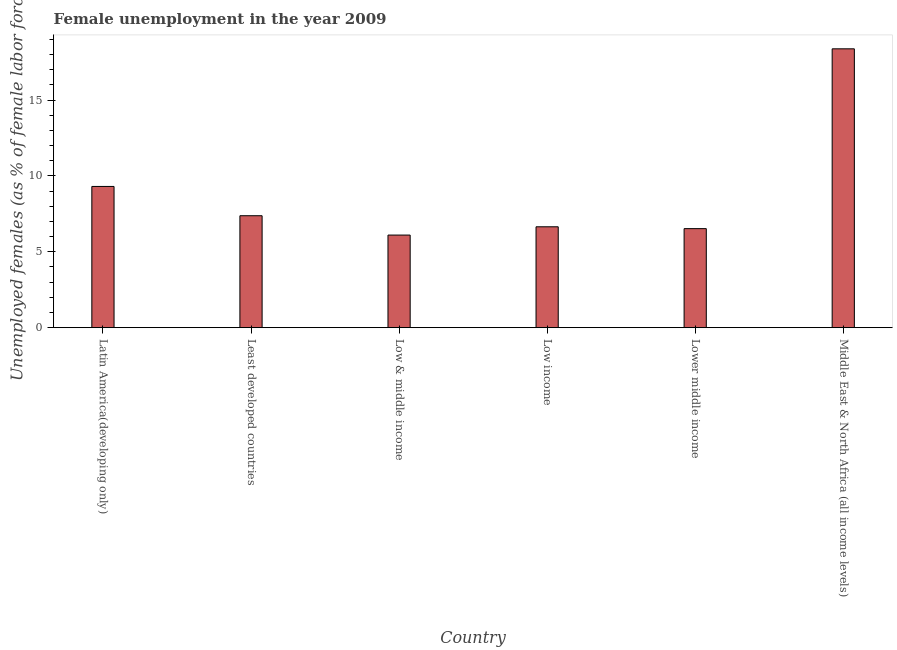Does the graph contain any zero values?
Your response must be concise. No. What is the title of the graph?
Keep it short and to the point. Female unemployment in the year 2009. What is the label or title of the Y-axis?
Provide a succinct answer. Unemployed females (as % of female labor force). What is the unemployed females population in Least developed countries?
Your response must be concise. 7.38. Across all countries, what is the maximum unemployed females population?
Give a very brief answer. 18.39. Across all countries, what is the minimum unemployed females population?
Provide a short and direct response. 6.11. In which country was the unemployed females population maximum?
Provide a succinct answer. Middle East & North Africa (all income levels). In which country was the unemployed females population minimum?
Provide a short and direct response. Low & middle income. What is the sum of the unemployed females population?
Your response must be concise. 54.36. What is the difference between the unemployed females population in Least developed countries and Low income?
Ensure brevity in your answer.  0.73. What is the average unemployed females population per country?
Give a very brief answer. 9.06. What is the median unemployed females population?
Your answer should be very brief. 7.02. Is the unemployed females population in Low & middle income less than that in Lower middle income?
Offer a very short reply. Yes. Is the difference between the unemployed females population in Latin America(developing only) and Lower middle income greater than the difference between any two countries?
Provide a succinct answer. No. What is the difference between the highest and the second highest unemployed females population?
Ensure brevity in your answer.  9.07. Is the sum of the unemployed females population in Low & middle income and Lower middle income greater than the maximum unemployed females population across all countries?
Your response must be concise. No. What is the difference between the highest and the lowest unemployed females population?
Your answer should be very brief. 12.28. In how many countries, is the unemployed females population greater than the average unemployed females population taken over all countries?
Ensure brevity in your answer.  2. How many bars are there?
Ensure brevity in your answer.  6. How many countries are there in the graph?
Your answer should be very brief. 6. Are the values on the major ticks of Y-axis written in scientific E-notation?
Make the answer very short. No. What is the Unemployed females (as % of female labor force) of Latin America(developing only)?
Provide a short and direct response. 9.31. What is the Unemployed females (as % of female labor force) in Least developed countries?
Your answer should be compact. 7.38. What is the Unemployed females (as % of female labor force) of Low & middle income?
Your answer should be very brief. 6.11. What is the Unemployed females (as % of female labor force) of Low income?
Give a very brief answer. 6.65. What is the Unemployed females (as % of female labor force) of Lower middle income?
Your answer should be compact. 6.53. What is the Unemployed females (as % of female labor force) of Middle East & North Africa (all income levels)?
Your answer should be very brief. 18.39. What is the difference between the Unemployed females (as % of female labor force) in Latin America(developing only) and Least developed countries?
Make the answer very short. 1.93. What is the difference between the Unemployed females (as % of female labor force) in Latin America(developing only) and Low & middle income?
Your response must be concise. 3.21. What is the difference between the Unemployed females (as % of female labor force) in Latin America(developing only) and Low income?
Make the answer very short. 2.66. What is the difference between the Unemployed females (as % of female labor force) in Latin America(developing only) and Lower middle income?
Your response must be concise. 2.78. What is the difference between the Unemployed females (as % of female labor force) in Latin America(developing only) and Middle East & North Africa (all income levels)?
Give a very brief answer. -9.07. What is the difference between the Unemployed females (as % of female labor force) in Least developed countries and Low & middle income?
Provide a succinct answer. 1.27. What is the difference between the Unemployed females (as % of female labor force) in Least developed countries and Low income?
Make the answer very short. 0.73. What is the difference between the Unemployed females (as % of female labor force) in Least developed countries and Lower middle income?
Your answer should be very brief. 0.85. What is the difference between the Unemployed females (as % of female labor force) in Least developed countries and Middle East & North Africa (all income levels)?
Offer a terse response. -11.01. What is the difference between the Unemployed females (as % of female labor force) in Low & middle income and Low income?
Keep it short and to the point. -0.55. What is the difference between the Unemployed females (as % of female labor force) in Low & middle income and Lower middle income?
Your answer should be compact. -0.42. What is the difference between the Unemployed females (as % of female labor force) in Low & middle income and Middle East & North Africa (all income levels)?
Your answer should be compact. -12.28. What is the difference between the Unemployed females (as % of female labor force) in Low income and Lower middle income?
Make the answer very short. 0.12. What is the difference between the Unemployed females (as % of female labor force) in Low income and Middle East & North Africa (all income levels)?
Your answer should be very brief. -11.73. What is the difference between the Unemployed females (as % of female labor force) in Lower middle income and Middle East & North Africa (all income levels)?
Provide a short and direct response. -11.86. What is the ratio of the Unemployed females (as % of female labor force) in Latin America(developing only) to that in Least developed countries?
Give a very brief answer. 1.26. What is the ratio of the Unemployed females (as % of female labor force) in Latin America(developing only) to that in Low & middle income?
Offer a terse response. 1.52. What is the ratio of the Unemployed females (as % of female labor force) in Latin America(developing only) to that in Low income?
Your response must be concise. 1.4. What is the ratio of the Unemployed females (as % of female labor force) in Latin America(developing only) to that in Lower middle income?
Your response must be concise. 1.43. What is the ratio of the Unemployed females (as % of female labor force) in Latin America(developing only) to that in Middle East & North Africa (all income levels)?
Your response must be concise. 0.51. What is the ratio of the Unemployed females (as % of female labor force) in Least developed countries to that in Low & middle income?
Your answer should be compact. 1.21. What is the ratio of the Unemployed females (as % of female labor force) in Least developed countries to that in Low income?
Your response must be concise. 1.11. What is the ratio of the Unemployed females (as % of female labor force) in Least developed countries to that in Lower middle income?
Make the answer very short. 1.13. What is the ratio of the Unemployed females (as % of female labor force) in Least developed countries to that in Middle East & North Africa (all income levels)?
Your response must be concise. 0.4. What is the ratio of the Unemployed females (as % of female labor force) in Low & middle income to that in Low income?
Ensure brevity in your answer.  0.92. What is the ratio of the Unemployed females (as % of female labor force) in Low & middle income to that in Lower middle income?
Offer a very short reply. 0.94. What is the ratio of the Unemployed females (as % of female labor force) in Low & middle income to that in Middle East & North Africa (all income levels)?
Make the answer very short. 0.33. What is the ratio of the Unemployed females (as % of female labor force) in Low income to that in Middle East & North Africa (all income levels)?
Provide a short and direct response. 0.36. What is the ratio of the Unemployed females (as % of female labor force) in Lower middle income to that in Middle East & North Africa (all income levels)?
Your answer should be compact. 0.35. 